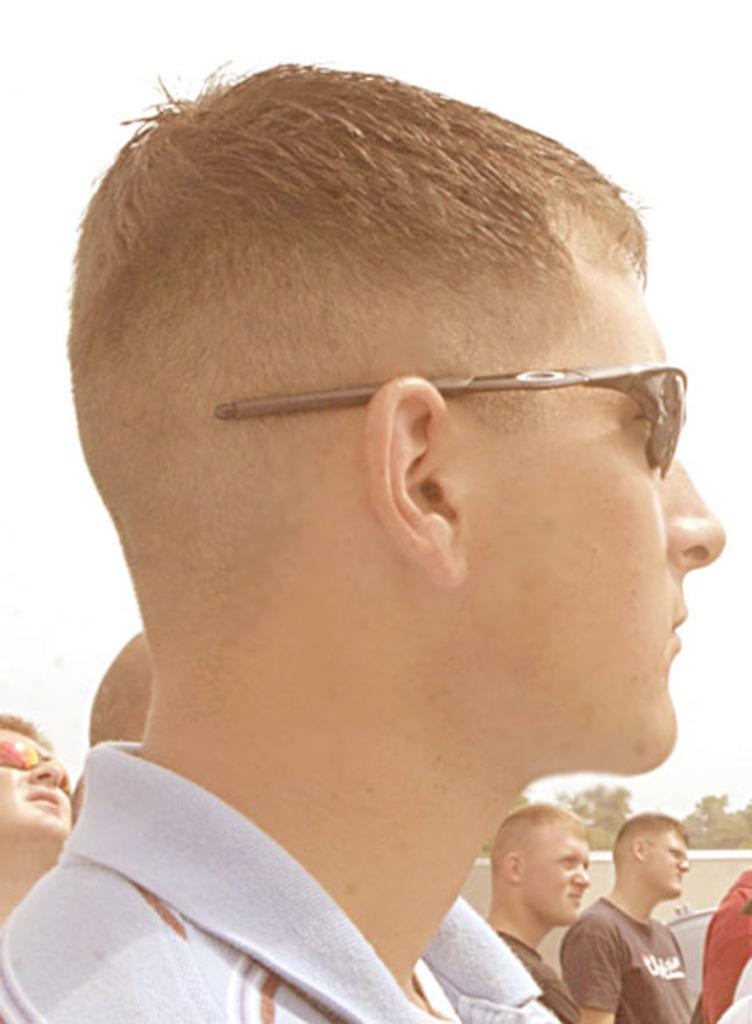What can be seen in the image? There are people standing in the image. What is the background of the image? There is a wall in the image, and trees are also visible. What is the condition of the sky in the image? The sky is visible in the image. What type of doctor is treating the bird in the image? There is no bird or doctor present in the image. What room are the people standing in? The provided facts do not specify the room or location where the people are standing. 